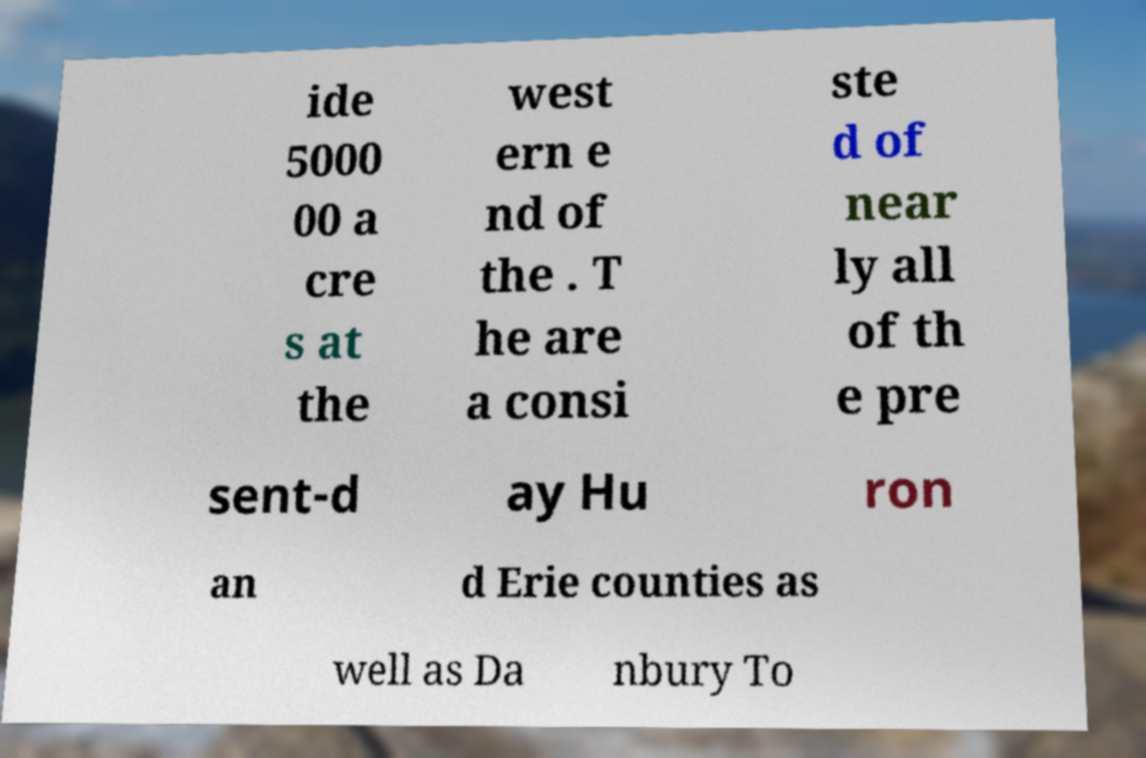What messages or text are displayed in this image? I need them in a readable, typed format. ide 5000 00 a cre s at the west ern e nd of the . T he are a consi ste d of near ly all of th e pre sent-d ay Hu ron an d Erie counties as well as Da nbury To 